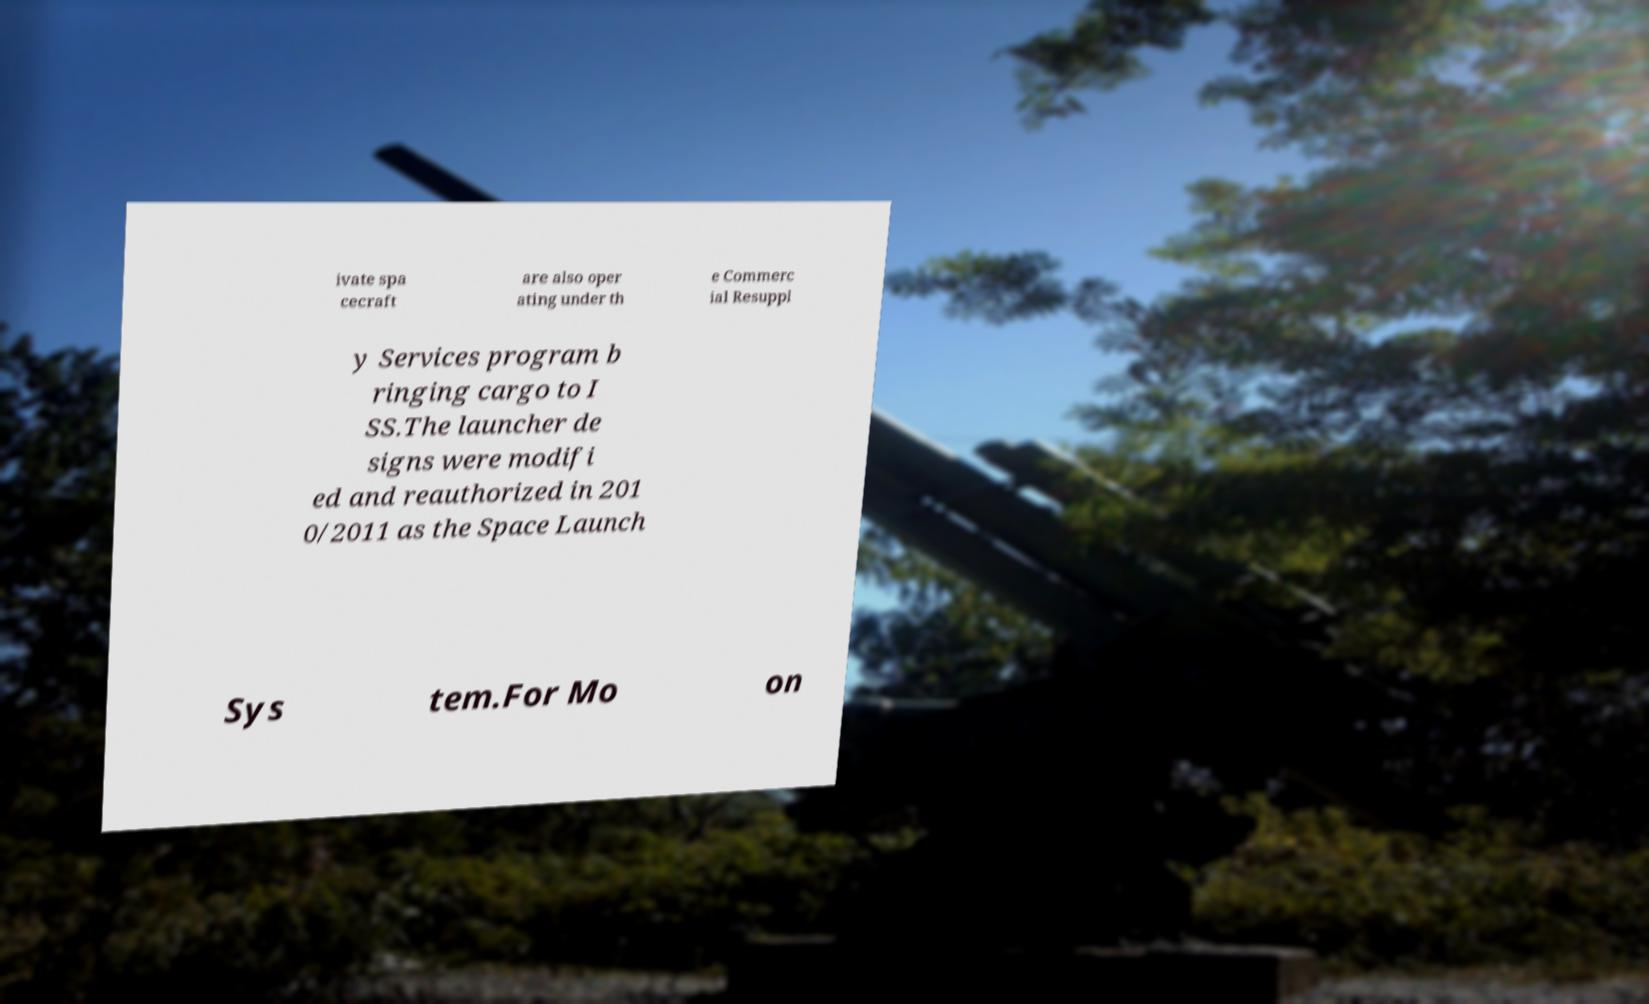Can you read and provide the text displayed in the image?This photo seems to have some interesting text. Can you extract and type it out for me? ivate spa cecraft are also oper ating under th e Commerc ial Resuppl y Services program b ringing cargo to I SS.The launcher de signs were modifi ed and reauthorized in 201 0/2011 as the Space Launch Sys tem.For Mo on 